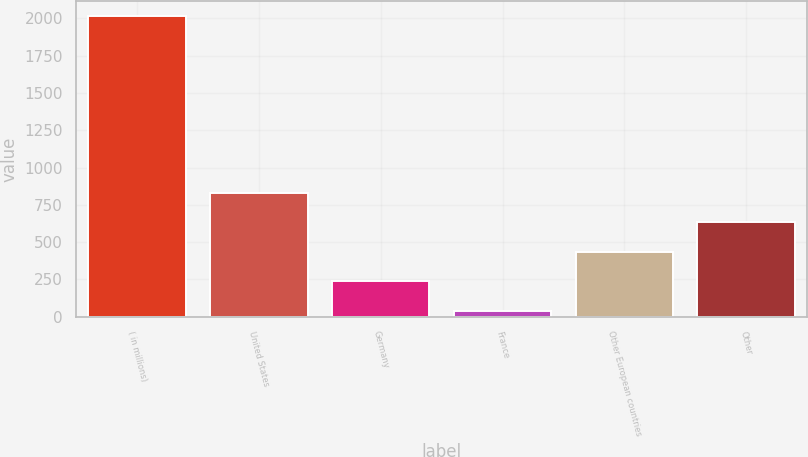Convert chart to OTSL. <chart><loc_0><loc_0><loc_500><loc_500><bar_chart><fcel>( in millions)<fcel>United States<fcel>Germany<fcel>France<fcel>Other European countries<fcel>Other<nl><fcel>2015<fcel>829.16<fcel>236.24<fcel>38.6<fcel>433.88<fcel>631.52<nl></chart> 